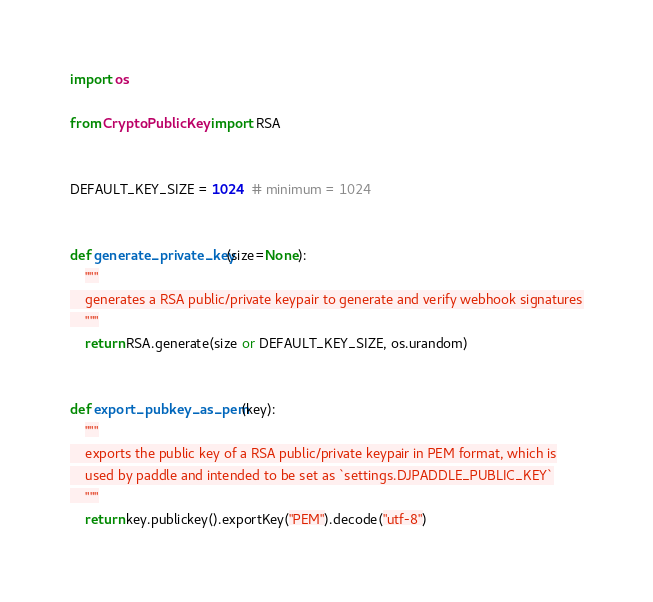<code> <loc_0><loc_0><loc_500><loc_500><_Python_>import os

from Crypto.PublicKey import RSA


DEFAULT_KEY_SIZE = 1024  # minimum = 1024


def generate_private_key(size=None):
    """
    generates a RSA public/private keypair to generate and verify webhook signatures
    """
    return RSA.generate(size or DEFAULT_KEY_SIZE, os.urandom)


def export_pubkey_as_pem(key):
    """
    exports the public key of a RSA public/private keypair in PEM format, which is
    used by paddle and intended to be set as `settings.DJPADDLE_PUBLIC_KEY`
    """
    return key.publickey().exportKey("PEM").decode("utf-8")
</code> 